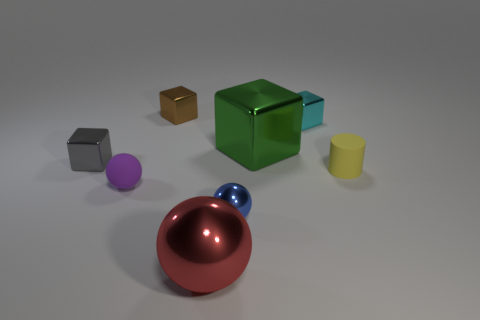Do the tiny brown thing and the blue shiny thing have the same shape?
Offer a terse response. No. How many other objects are the same size as the gray object?
Provide a short and direct response. 5. The tiny metal ball has what color?
Provide a succinct answer. Blue. How many large things are either blue rubber spheres or purple things?
Provide a succinct answer. 0. Do the ball that is to the left of the brown object and the block left of the tiny purple sphere have the same size?
Your answer should be compact. Yes. There is a green metal thing that is the same shape as the small cyan shiny object; what size is it?
Ensure brevity in your answer.  Large. Are there more green cubes on the right side of the gray thing than yellow rubber things to the right of the green metallic thing?
Ensure brevity in your answer.  No. What material is the small object that is right of the small brown metal thing and to the left of the cyan thing?
Your answer should be compact. Metal. There is a matte thing that is the same shape as the big red metal thing; what is its color?
Offer a very short reply. Purple. What is the size of the purple matte sphere?
Ensure brevity in your answer.  Small. 